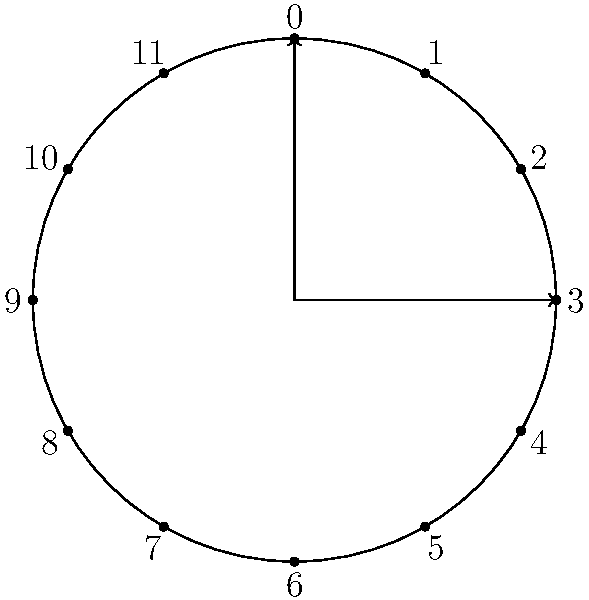Consider a clock face represented as a group $(G, +)$ where $G = \{0, 1, 2, ..., 11\}$ and the operation is addition modulo 12. Let $H = \{0, 4, 8\}$ be a subgroup of $G$. Find all distinct left cosets of $H$ in $G$ and explain how they partition the group. How does this relate to the concept of telling time? Let's approach this step-by-step:

1) First, recall that a left coset of $H$ in $G$ is defined as $gH = \{gh : h \in H\}$ for some $g \in G$.

2) We need to find $gH$ for each $g \in G$:

   For $g = 0$: $0H = \{0, 4, 8\}$
   For $g = 1$: $1H = \{1, 5, 9\}$
   For $g = 2$: $2H = \{2, 6, 10\}$
   For $g = 3$: $3H = \{3, 7, 11\}$
   For $g = 4$: $4H = \{4, 8, 0\} = \{0, 4, 8\} = H$
   For $g = 5$: $5H = \{5, 9, 1\} = \{1, 5, 9\}$
   ...and so on.

3) We can see that there are only four distinct cosets:
   $\{0, 4, 8\}$, $\{1, 5, 9\}$, $\{2, 6, 10\}$, and $\{3, 7, 11\}$

4) These cosets partition the group $G$. Each element of $G$ appears in exactly one coset, and the union of all cosets is $G$.

5) Relating to telling time:
   - The coset $\{0, 4, 8\}$ represents hours that are multiples of 4
   - The coset $\{1, 5, 9\}$ represents hours that give remainder 1 when divided by 4
   - The coset $\{2, 6, 10\}$ represents hours that give remainder 2 when divided by 4
   - The coset $\{3, 7, 11\}$ represents hours that give remainder 3 when divided by 4

This partitioning can be thought of as dividing the day into four equal parts, each 4 hours long.
Answer: $\{0, 4, 8\}$, $\{1, 5, 9\}$, $\{2, 6, 10\}$, $\{3, 7, 11\}$ 